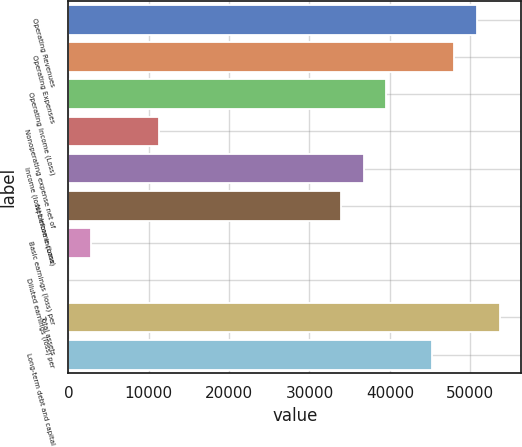Convert chart to OTSL. <chart><loc_0><loc_0><loc_500><loc_500><bar_chart><fcel>Operating Revenues<fcel>Operating Expenses<fcel>Operating Income (Loss)<fcel>Nonoperating expense net of<fcel>Income (loss) before income<fcel>Net Income (Loss)<fcel>Basic earnings (loss) per<fcel>Diluted earnings (loss) per<fcel>Total assets<fcel>Long-term debt and capital<nl><fcel>50858.3<fcel>48033<fcel>39557.1<fcel>11304.2<fcel>36731.8<fcel>33906.6<fcel>2828.36<fcel>3.07<fcel>53683.6<fcel>45207.7<nl></chart> 